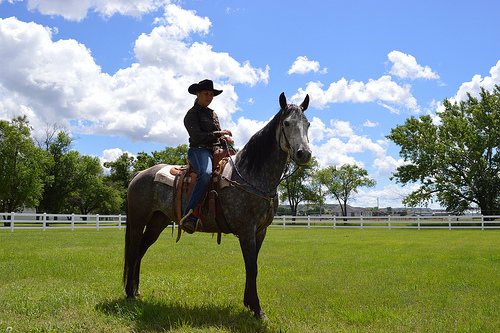<image>
Is there a horse next to the tree? No. The horse is not positioned next to the tree. They are located in different areas of the scene. Is there a tree in front of the horse? No. The tree is not in front of the horse. The spatial positioning shows a different relationship between these objects. 